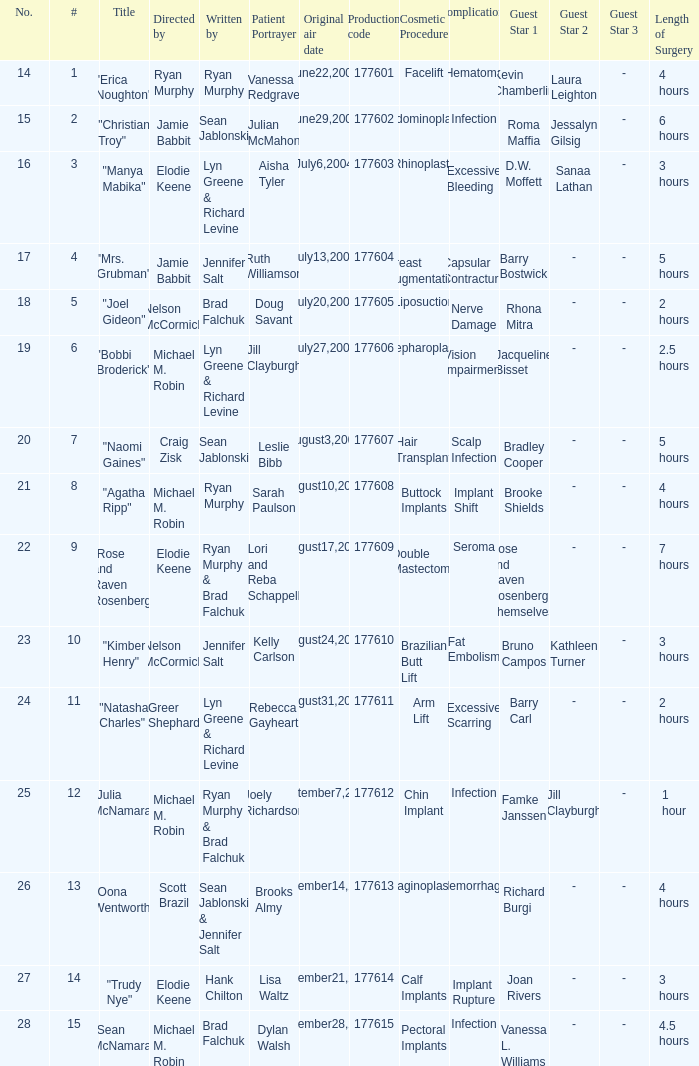Who directed the episode with production code 177605? Nelson McCormick. 